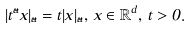Convert formula to latex. <formula><loc_0><loc_0><loc_500><loc_500>| t ^ { \vec { a } } x | _ { \vec { a } } = t | x | _ { \vec { a } } , \, x \in \mathbb { R } ^ { d } , \, t > 0 .</formula> 